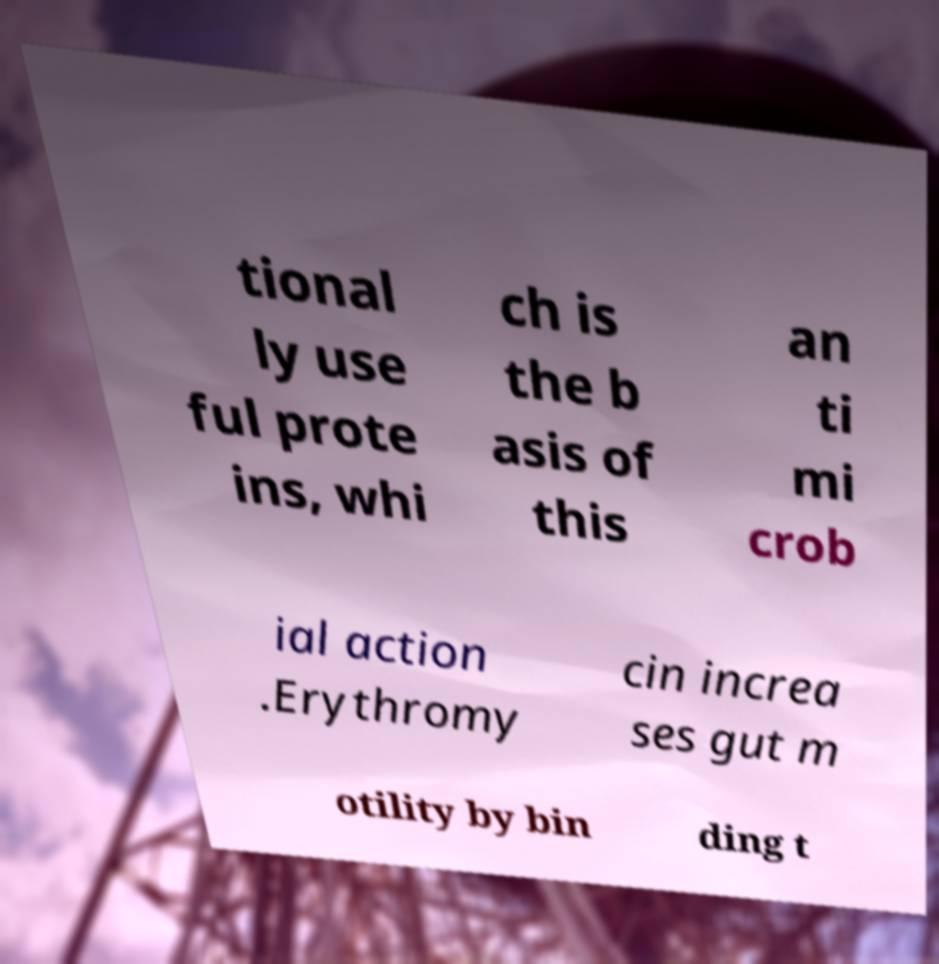Please read and relay the text visible in this image. What does it say? tional ly use ful prote ins, whi ch is the b asis of this an ti mi crob ial action .Erythromy cin increa ses gut m otility by bin ding t 